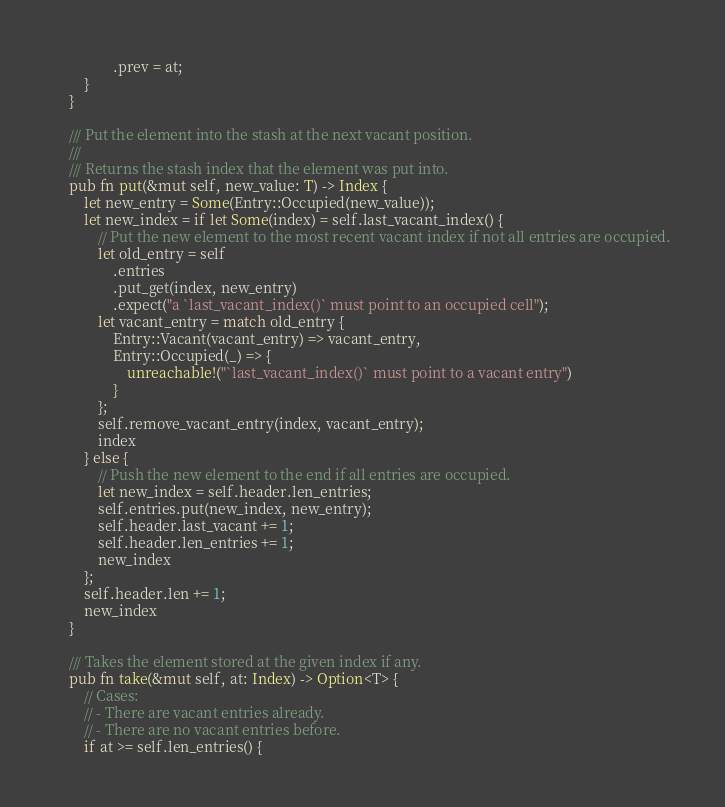<code> <loc_0><loc_0><loc_500><loc_500><_Rust_>                .prev = at;
        }
    }

    /// Put the element into the stash at the next vacant position.
    ///
    /// Returns the stash index that the element was put into.
    pub fn put(&mut self, new_value: T) -> Index {
        let new_entry = Some(Entry::Occupied(new_value));
        let new_index = if let Some(index) = self.last_vacant_index() {
            // Put the new element to the most recent vacant index if not all entries are occupied.
            let old_entry = self
                .entries
                .put_get(index, new_entry)
                .expect("a `last_vacant_index()` must point to an occupied cell");
            let vacant_entry = match old_entry {
                Entry::Vacant(vacant_entry) => vacant_entry,
                Entry::Occupied(_) => {
                    unreachable!("`last_vacant_index()` must point to a vacant entry")
                }
            };
            self.remove_vacant_entry(index, vacant_entry);
            index
        } else {
            // Push the new element to the end if all entries are occupied.
            let new_index = self.header.len_entries;
            self.entries.put(new_index, new_entry);
            self.header.last_vacant += 1;
            self.header.len_entries += 1;
            new_index
        };
        self.header.len += 1;
        new_index
    }

    /// Takes the element stored at the given index if any.
    pub fn take(&mut self, at: Index) -> Option<T> {
        // Cases:
        // - There are vacant entries already.
        // - There are no vacant entries before.
        if at >= self.len_entries() {</code> 